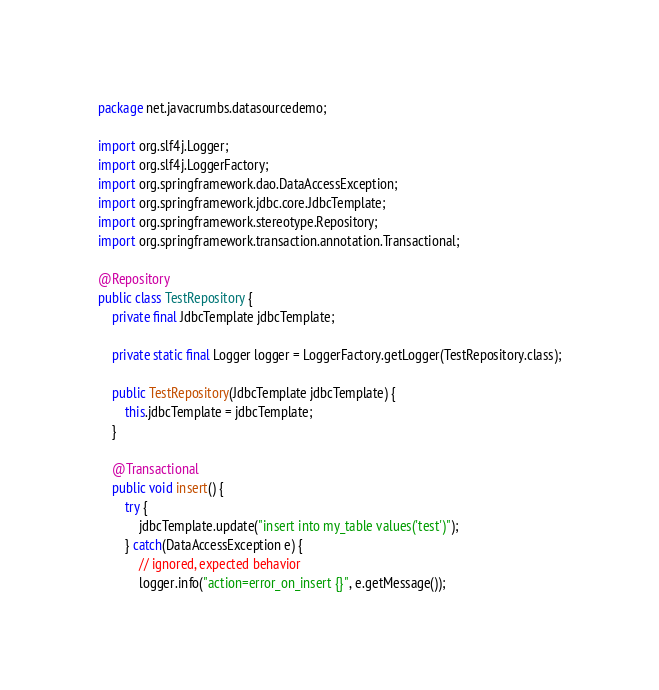<code> <loc_0><loc_0><loc_500><loc_500><_Java_>package net.javacrumbs.datasourcedemo;

import org.slf4j.Logger;
import org.slf4j.LoggerFactory;
import org.springframework.dao.DataAccessException;
import org.springframework.jdbc.core.JdbcTemplate;
import org.springframework.stereotype.Repository;
import org.springframework.transaction.annotation.Transactional;

@Repository
public class TestRepository {
    private final JdbcTemplate jdbcTemplate;

    private static final Logger logger = LoggerFactory.getLogger(TestRepository.class);

    public TestRepository(JdbcTemplate jdbcTemplate) {
        this.jdbcTemplate = jdbcTemplate;
    }

    @Transactional
    public void insert() {
        try {
            jdbcTemplate.update("insert into my_table values('test')");
        } catch(DataAccessException e) {
            // ignored, expected behavior
            logger.info("action=error_on_insert {}", e.getMessage());</code> 